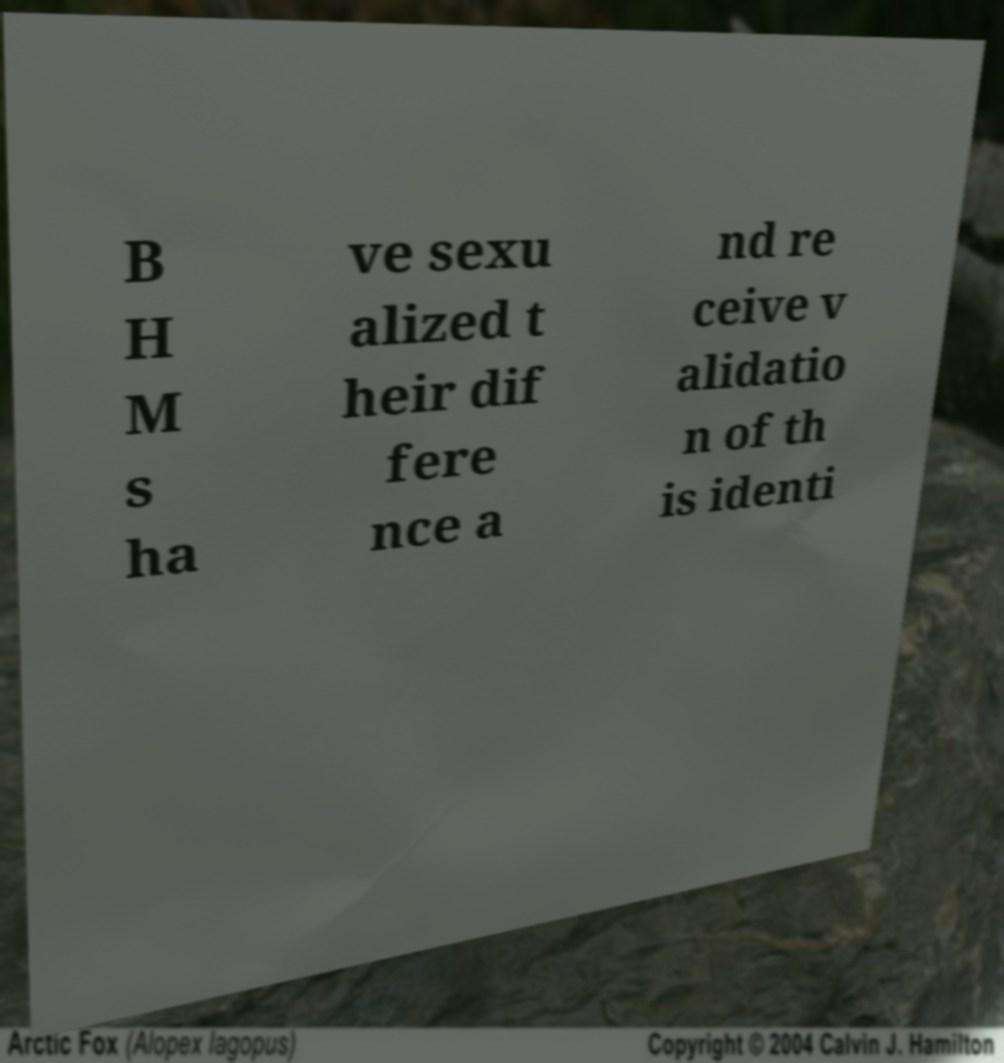Could you extract and type out the text from this image? B H M s ha ve sexu alized t heir dif fere nce a nd re ceive v alidatio n of th is identi 